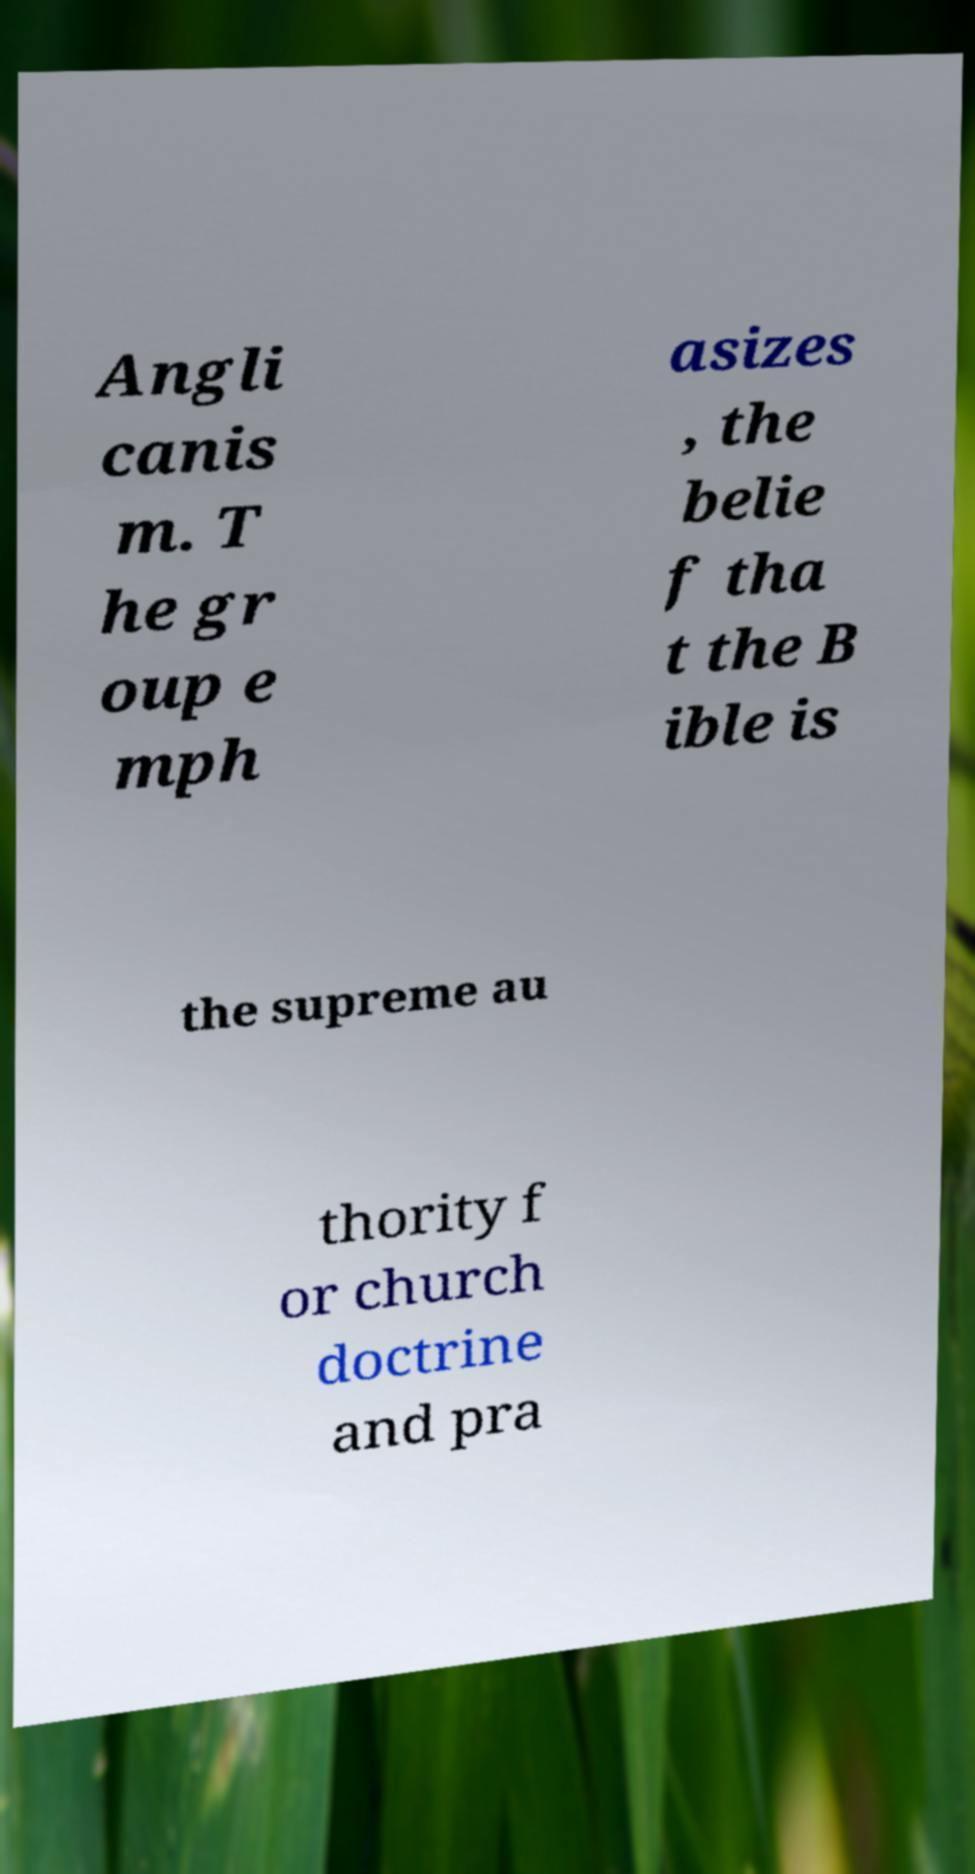Could you extract and type out the text from this image? Angli canis m. T he gr oup e mph asizes , the belie f tha t the B ible is the supreme au thority f or church doctrine and pra 